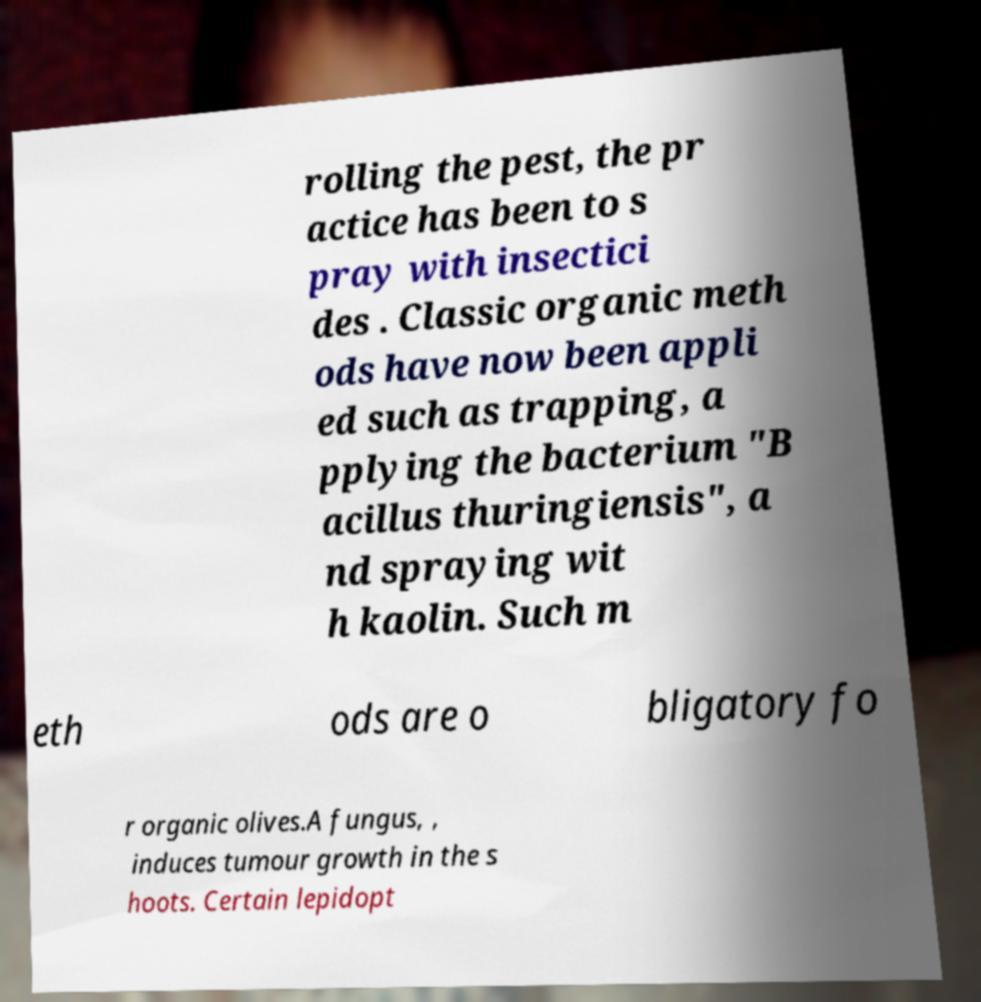Can you read and provide the text displayed in the image?This photo seems to have some interesting text. Can you extract and type it out for me? rolling the pest, the pr actice has been to s pray with insectici des . Classic organic meth ods have now been appli ed such as trapping, a pplying the bacterium "B acillus thuringiensis", a nd spraying wit h kaolin. Such m eth ods are o bligatory fo r organic olives.A fungus, , induces tumour growth in the s hoots. Certain lepidopt 